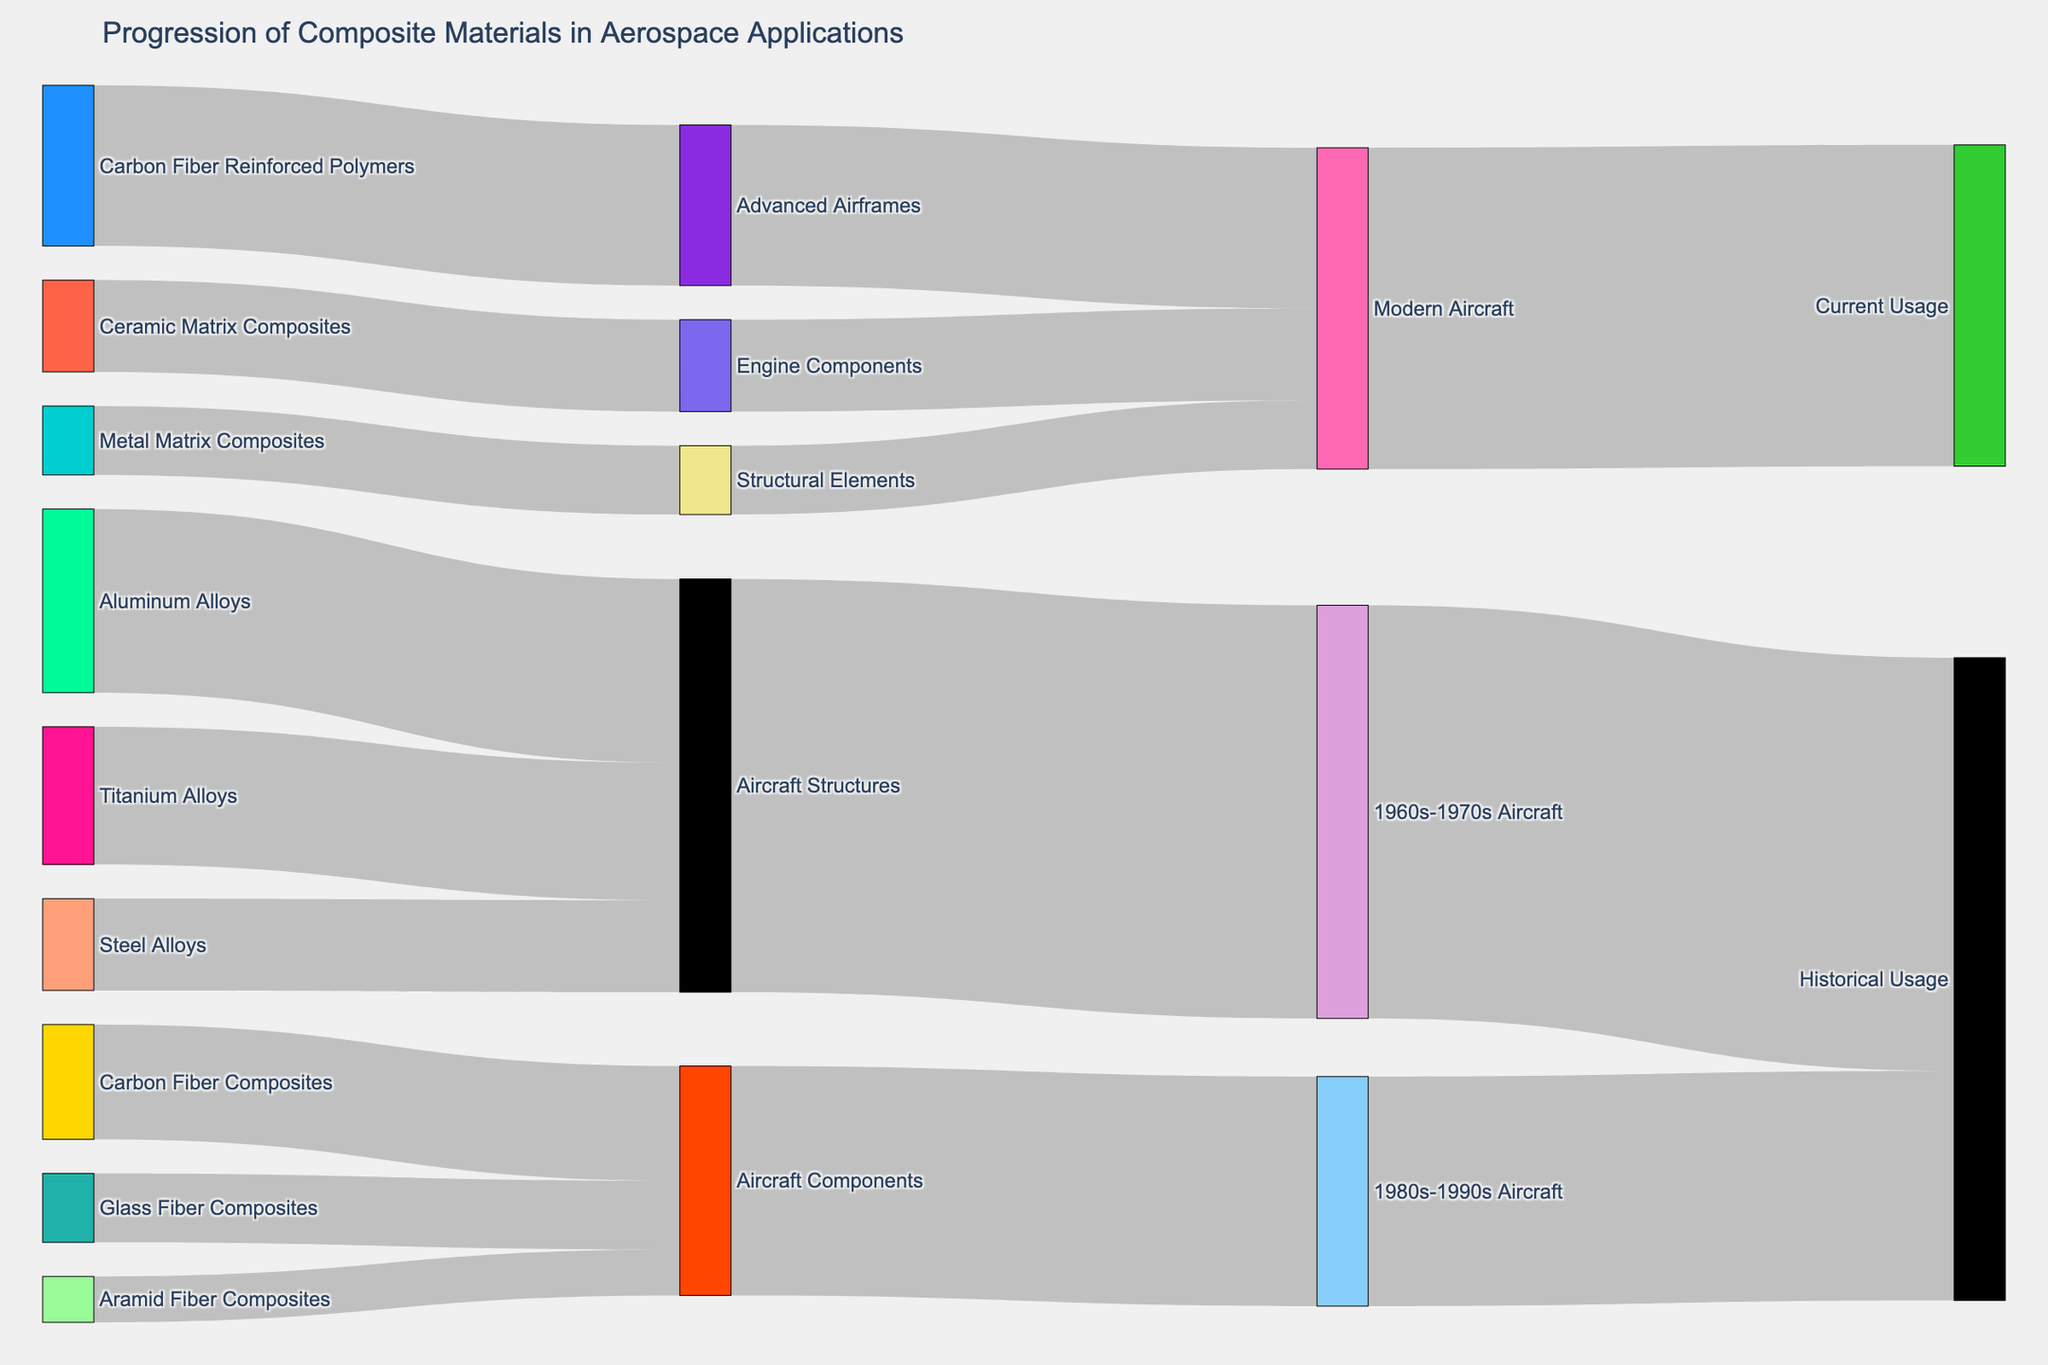How many materials are used in the 1960s-1970s aircraft? The figure shows arrows pointing to "1960s-1970s Aircraft" from the node "Aircraft Structures". By totaling up the values of aluminum alloys, titanium alloys, and steel allies, the sum is 40+30+20 = 90, thus grouped under Aircraft Structures
Answer: 3 What are the primary components for modern aircraft? The figure shows arrows pointing to "Modern Aircraft" from "Advanced Airframes," "Engine Components," and "Structural Elements." These components originate from "Carbon Fiber Reinforced Polymers," "Ceramic Matrix Composites," and "Metal Matrix Composites" respectively
Answer: Advanced Airframes, Engine Components, Structural Elements Compare the value distribution between traditional metal alloys and fiber composites used in earlier aerospace applications. Traditional metal alloys used in Aircraft Structures are 40 (Aluminum Alloys) + 30 (Titanium Alloys) + 20 (Steel Alloys) = 90. Fiber composites used in Aircraft Components are 15 (Glass Fiber Composites) + 25 (Carbon Fiber Composites) + 10 (Aramid Fiber Composites) = 50. Metals = 90, Composites = 50
Answer: Traditional metal alloys: 90, Fiber composites: 50 Which composite material has the greatest usage in aircraft components during the 1980s-1990s? The figure shows three different fiber composites pointing towards "Aircraft Components" with Carbon Fiber Composites having the highest value of 25
Answer: Carbon Fiber Composites What is the sum value of all modern aircraft materials? The sum of the values directed towards "Modern Aircraft" (35 from Advanced Airframes, 20 from Engine Components, and 15 from Structural Elements) is 35 + 20 + 15 = 70
Answer: 70 